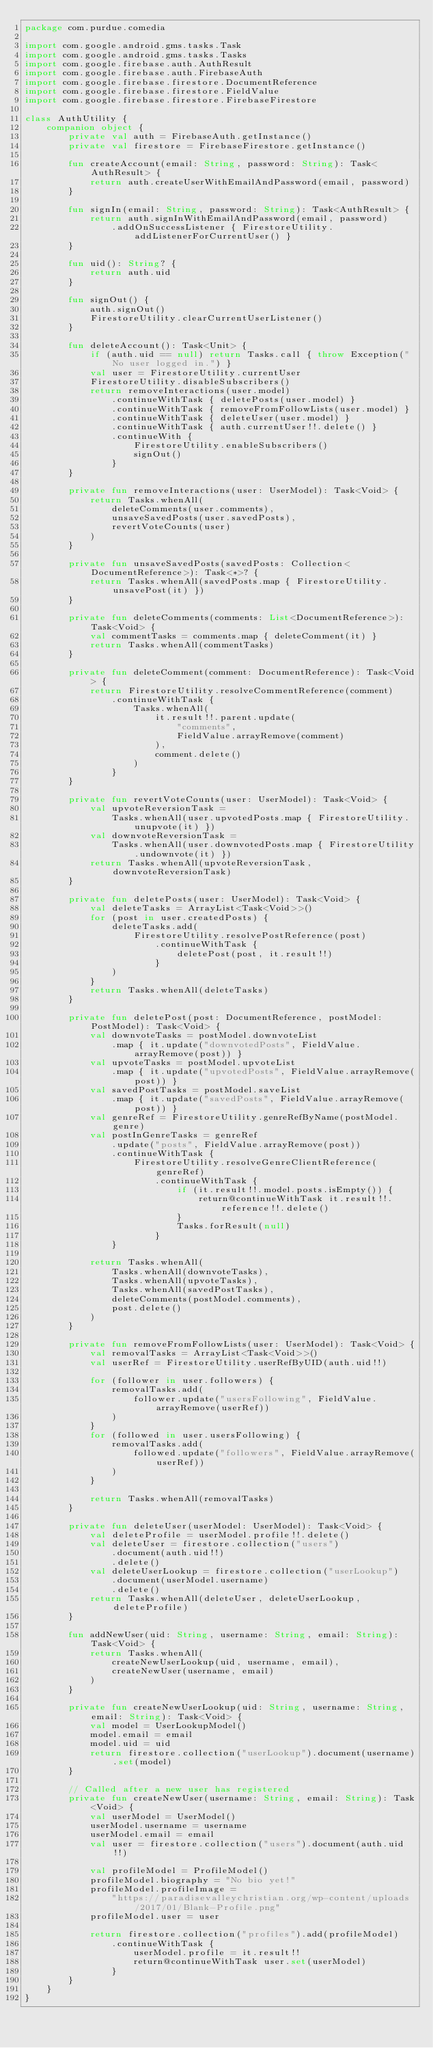Convert code to text. <code><loc_0><loc_0><loc_500><loc_500><_Kotlin_>package com.purdue.comedia

import com.google.android.gms.tasks.Task
import com.google.android.gms.tasks.Tasks
import com.google.firebase.auth.AuthResult
import com.google.firebase.auth.FirebaseAuth
import com.google.firebase.firestore.DocumentReference
import com.google.firebase.firestore.FieldValue
import com.google.firebase.firestore.FirebaseFirestore

class AuthUtility {
    companion object {
        private val auth = FirebaseAuth.getInstance()
        private val firestore = FirebaseFirestore.getInstance()

        fun createAccount(email: String, password: String): Task<AuthResult> {
            return auth.createUserWithEmailAndPassword(email, password)
        }

        fun signIn(email: String, password: String): Task<AuthResult> {
            return auth.signInWithEmailAndPassword(email, password)
                .addOnSuccessListener { FirestoreUtility.addListenerForCurrentUser() }
        }

        fun uid(): String? {
            return auth.uid
        }

        fun signOut() {
            auth.signOut()
            FirestoreUtility.clearCurrentUserListener()
        }

        fun deleteAccount(): Task<Unit> {
            if (auth.uid == null) return Tasks.call { throw Exception("No user logged in.") }
            val user = FirestoreUtility.currentUser
            FirestoreUtility.disableSubscribers()
            return removeInteractions(user.model)
                .continueWithTask { deletePosts(user.model) }
                .continueWithTask { removeFromFollowLists(user.model) }
                .continueWithTask { deleteUser(user.model) }
                .continueWithTask { auth.currentUser!!.delete() }
                .continueWith {
                    FirestoreUtility.enableSubscribers()
                    signOut()
                }
        }

        private fun removeInteractions(user: UserModel): Task<Void> {
            return Tasks.whenAll(
                deleteComments(user.comments),
                unsaveSavedPosts(user.savedPosts),
                revertVoteCounts(user)
            )
        }

        private fun unsaveSavedPosts(savedPosts: Collection<DocumentReference>): Task<*>? {
            return Tasks.whenAll(savedPosts.map { FirestoreUtility.unsavePost(it) })
        }

        private fun deleteComments(comments: List<DocumentReference>): Task<Void> {
            val commentTasks = comments.map { deleteComment(it) }
            return Tasks.whenAll(commentTasks)
        }

        private fun deleteComment(comment: DocumentReference): Task<Void> {
            return FirestoreUtility.resolveCommentReference(comment)
                .continueWithTask {
                    Tasks.whenAll(
                        it.result!!.parent.update(
                            "comments",
                            FieldValue.arrayRemove(comment)
                        ),
                        comment.delete()
                    )
                }
        }

        private fun revertVoteCounts(user: UserModel): Task<Void> {
            val upvoteReversionTask =
                Tasks.whenAll(user.upvotedPosts.map { FirestoreUtility.unupvote(it) })
            val downvoteReversionTask =
                Tasks.whenAll(user.downvotedPosts.map { FirestoreUtility.undownvote(it) })
            return Tasks.whenAll(upvoteReversionTask, downvoteReversionTask)
        }

        private fun deletePosts(user: UserModel): Task<Void> {
            val deleteTasks = ArrayList<Task<Void>>()
            for (post in user.createdPosts) {
                deleteTasks.add(
                    FirestoreUtility.resolvePostReference(post)
                        .continueWithTask {
                            deletePost(post, it.result!!)
                        }
                )
            }
            return Tasks.whenAll(deleteTasks)
        }

        private fun deletePost(post: DocumentReference, postModel: PostModel): Task<Void> {
            val downvoteTasks = postModel.downvoteList
                .map { it.update("downvotedPosts", FieldValue.arrayRemove(post)) }
            val upvoteTasks = postModel.upvoteList
                .map { it.update("upvotedPosts", FieldValue.arrayRemove(post)) }
            val savedPostTasks = postModel.saveList
                .map { it.update("savedPosts", FieldValue.arrayRemove(post)) }
            val genreRef = FirestoreUtility.genreRefByName(postModel.genre)
            val postInGenreTasks = genreRef
                .update("posts", FieldValue.arrayRemove(post))
                .continueWithTask {
                    FirestoreUtility.resolveGenreClientReference(genreRef)
                        .continueWithTask {
                            if (it.result!!.model.posts.isEmpty()) {
                                return@continueWithTask it.result!!.reference!!.delete()
                            }
                            Tasks.forResult(null)
                        }
                }

            return Tasks.whenAll(
                Tasks.whenAll(downvoteTasks),
                Tasks.whenAll(upvoteTasks),
                Tasks.whenAll(savedPostTasks),
                deleteComments(postModel.comments),
                post.delete()
            )
        }

        private fun removeFromFollowLists(user: UserModel): Task<Void> {
            val removalTasks = ArrayList<Task<Void>>()
            val userRef = FirestoreUtility.userRefByUID(auth.uid!!)

            for (follower in user.followers) {
                removalTasks.add(
                    follower.update("usersFollowing", FieldValue.arrayRemove(userRef))
                )
            }
            for (followed in user.usersFollowing) {
                removalTasks.add(
                    followed.update("followers", FieldValue.arrayRemove(userRef))
                )
            }

            return Tasks.whenAll(removalTasks)
        }

        private fun deleteUser(userModel: UserModel): Task<Void> {
            val deleteProfile = userModel.profile!!.delete()
            val deleteUser = firestore.collection("users")
                .document(auth.uid!!)
                .delete()
            val deleteUserLookup = firestore.collection("userLookup")
                .document(userModel.username)
                .delete()
            return Tasks.whenAll(deleteUser, deleteUserLookup, deleteProfile)
        }

        fun addNewUser(uid: String, username: String, email: String): Task<Void> {
            return Tasks.whenAll(
                createNewUserLookup(uid, username, email),
                createNewUser(username, email)
            )
        }

        private fun createNewUserLookup(uid: String, username: String, email: String): Task<Void> {
            val model = UserLookupModel()
            model.email = email
            model.uid = uid
            return firestore.collection("userLookup").document(username).set(model)
        }

        // Called after a new user has registered
        private fun createNewUser(username: String, email: String): Task<Void> {
            val userModel = UserModel()
            userModel.username = username
            userModel.email = email
            val user = firestore.collection("users").document(auth.uid!!)

            val profileModel = ProfileModel()
            profileModel.biography = "No bio yet!"
            profileModel.profileImage =
                "https://paradisevalleychristian.org/wp-content/uploads/2017/01/Blank-Profile.png"
            profileModel.user = user

            return firestore.collection("profiles").add(profileModel)
                .continueWithTask {
                    userModel.profile = it.result!!
                    return@continueWithTask user.set(userModel)
                }
        }
    }
}
</code> 